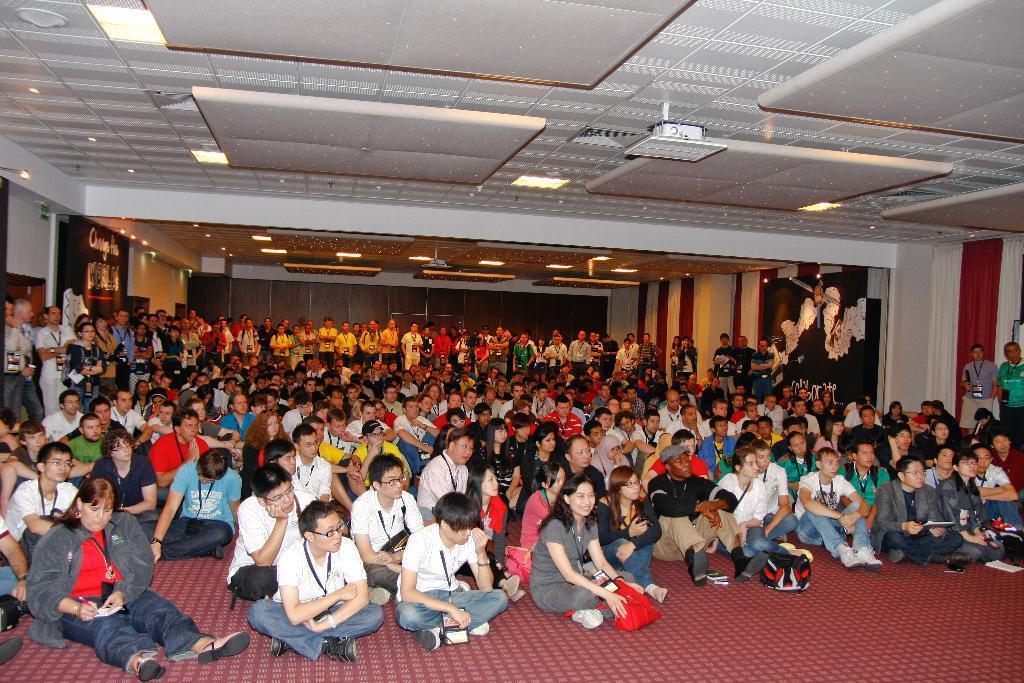Can you describe this image briefly? At the bottom of the image we can see people sitting and some of them are standing. At the top there are lights. In the background we can see a wall. 